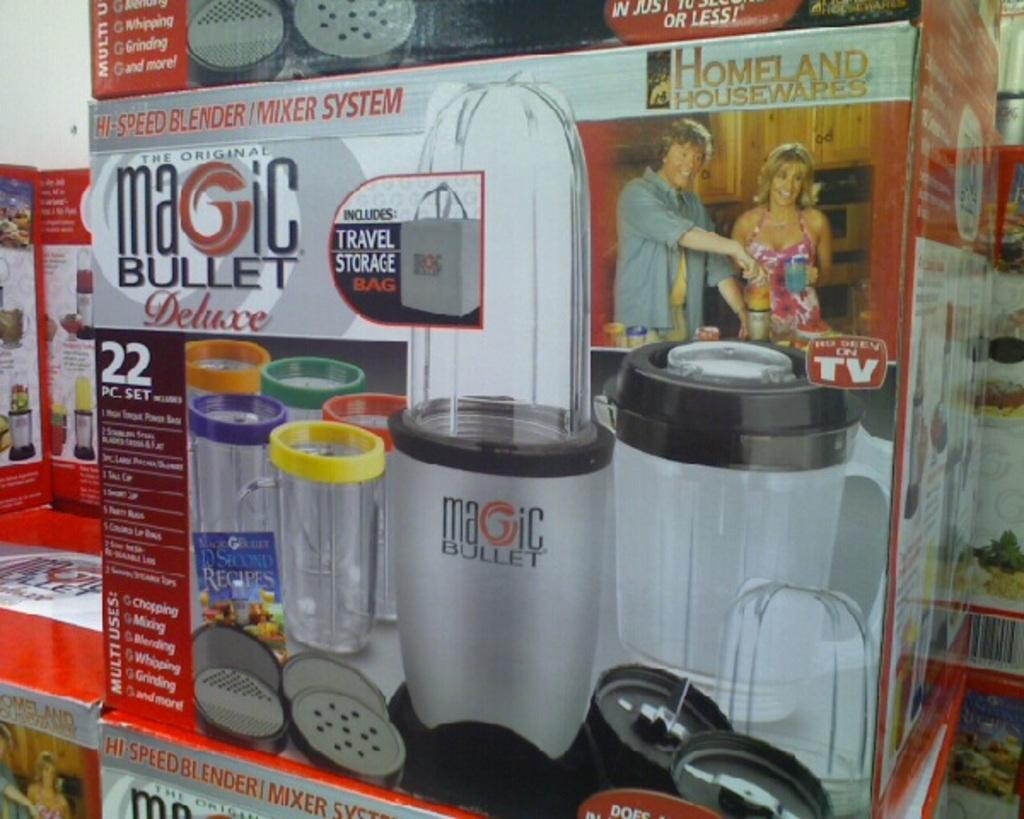Provide a one-sentence caption for the provided image. A box for the Magic Bullet Deluxe 22 pc. set is shown. 